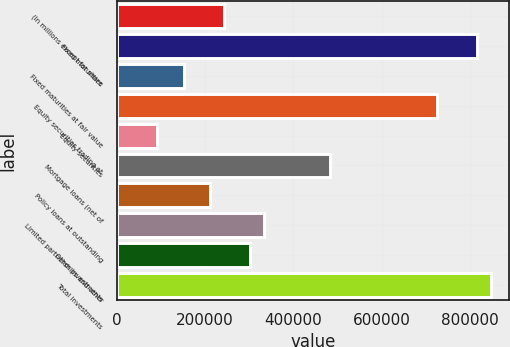Convert chart to OTSL. <chart><loc_0><loc_0><loc_500><loc_500><bar_chart><fcel>(In millions except for share<fcel>Fixed maturities<fcel>Fixed maturities at fair value<fcel>Equity securities trading at<fcel>Equity securities<fcel>Mortgage loans (net of<fcel>Policy loans at outstanding<fcel>Limited partnerships and other<fcel>Other investments<fcel>Total investments<nl><fcel>242088<fcel>817036<fcel>151307<fcel>726255<fcel>90786.2<fcel>484171<fcel>211828<fcel>332869<fcel>302609<fcel>847296<nl></chart> 